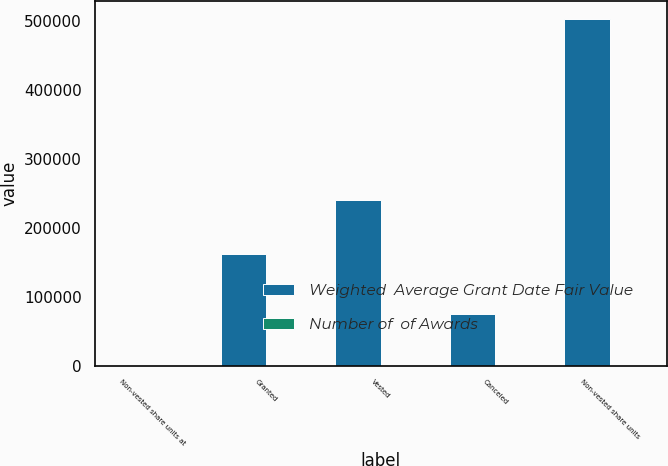Convert chart. <chart><loc_0><loc_0><loc_500><loc_500><stacked_bar_chart><ecel><fcel>Non-vested share units at<fcel>Granted<fcel>Vested<fcel>Canceled<fcel>Non-vested share units<nl><fcel>Weighted  Average Grant Date Fair Value<fcel>71.36<fcel>161479<fcel>241288<fcel>74866<fcel>504211<nl><fcel>Number of  of Awards<fcel>40.21<fcel>71.36<fcel>33.94<fcel>37.59<fcel>53.57<nl></chart> 